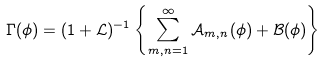<formula> <loc_0><loc_0><loc_500><loc_500>\Gamma ( \phi ) = ( 1 + \mathcal { L } ) ^ { - 1 } \left \{ \sum _ { m , n = 1 } ^ { \infty } \mathcal { A } _ { m , n } ( \phi ) + \mathcal { B } ( \phi ) \right \}</formula> 